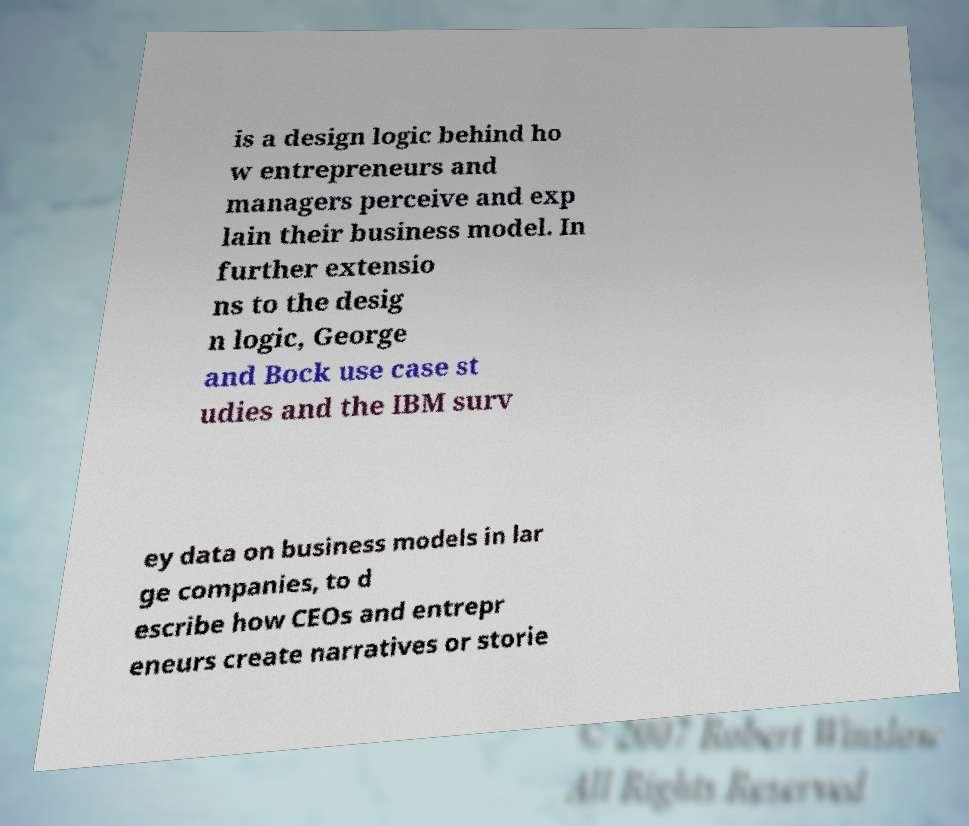For documentation purposes, I need the text within this image transcribed. Could you provide that? is a design logic behind ho w entrepreneurs and managers perceive and exp lain their business model. In further extensio ns to the desig n logic, George and Bock use case st udies and the IBM surv ey data on business models in lar ge companies, to d escribe how CEOs and entrepr eneurs create narratives or storie 